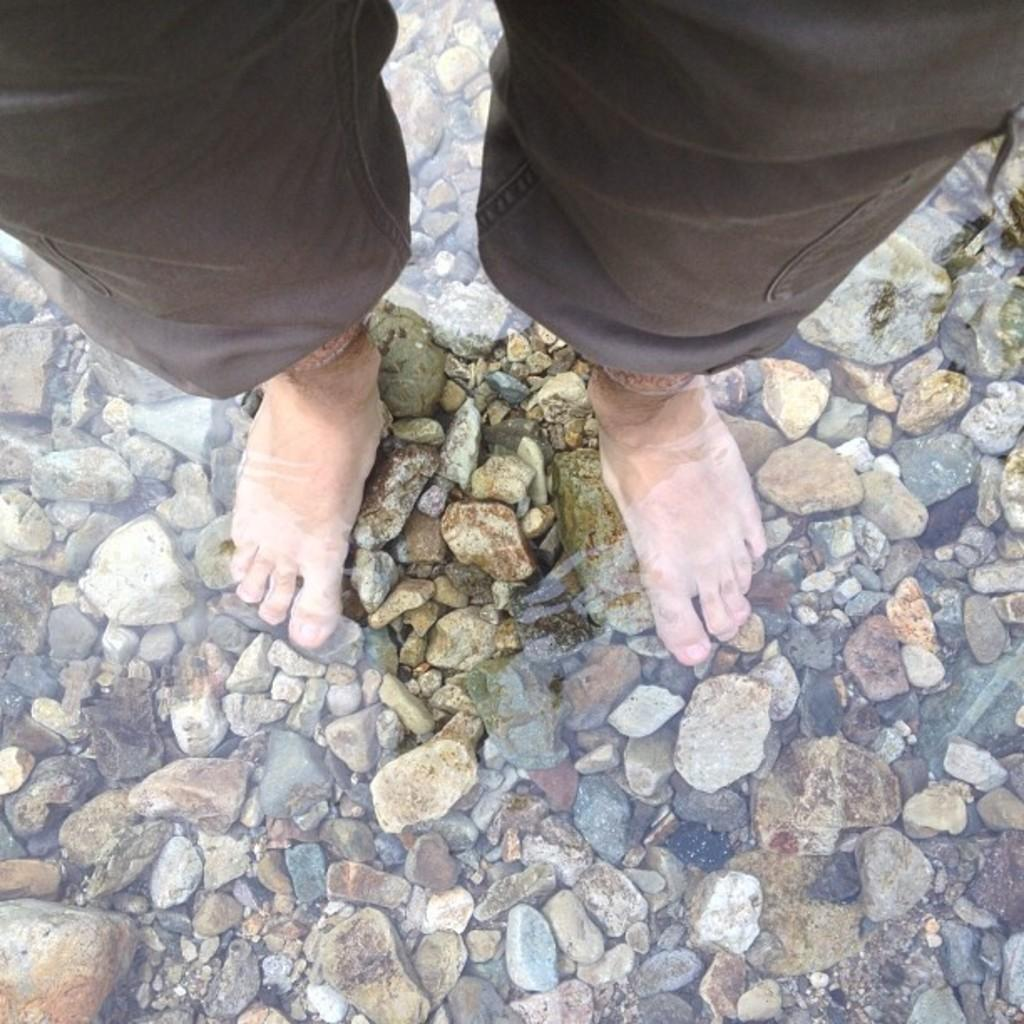What is the primary element in the image? There is water in the image. What can be seen through the water? Stones are visible through the water. What other object is present in the image? There is a rock in the image. Can you describe the person in the image? The person's legs are visible in the image, and they are wearing brown-colored pants. What type of produce is being weighed on the scale in the image? There is no produce or scale present in the image. 